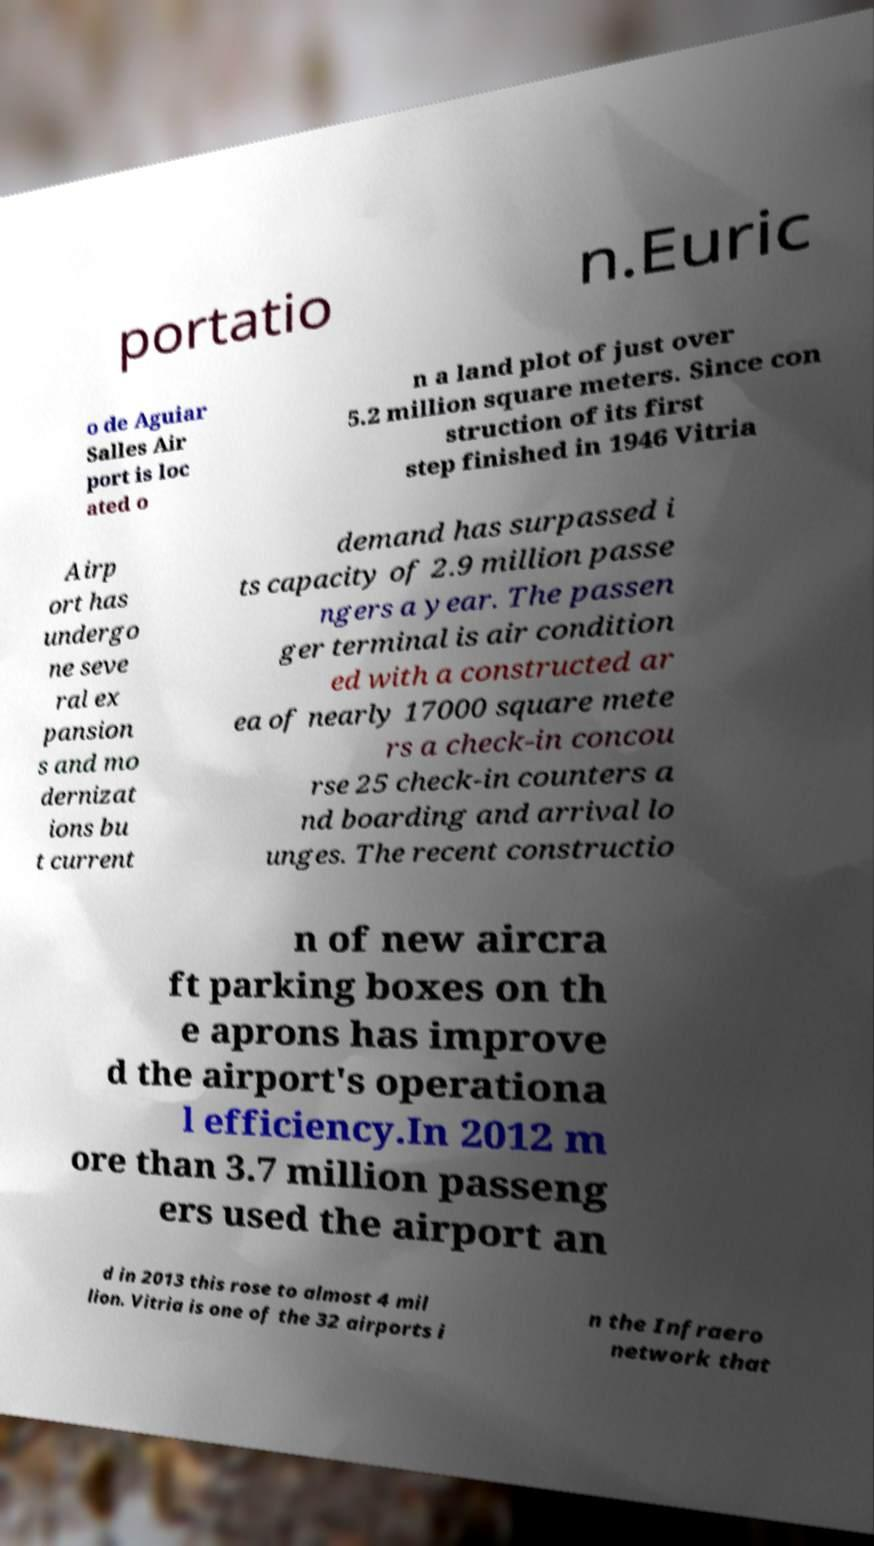Please identify and transcribe the text found in this image. portatio n.Euric o de Aguiar Salles Air port is loc ated o n a land plot of just over 5.2 million square meters. Since con struction of its first step finished in 1946 Vitria Airp ort has undergo ne seve ral ex pansion s and mo dernizat ions bu t current demand has surpassed i ts capacity of 2.9 million passe ngers a year. The passen ger terminal is air condition ed with a constructed ar ea of nearly 17000 square mete rs a check-in concou rse 25 check-in counters a nd boarding and arrival lo unges. The recent constructio n of new aircra ft parking boxes on th e aprons has improve d the airport's operationa l efficiency.In 2012 m ore than 3.7 million passeng ers used the airport an d in 2013 this rose to almost 4 mil lion. Vitria is one of the 32 airports i n the Infraero network that 